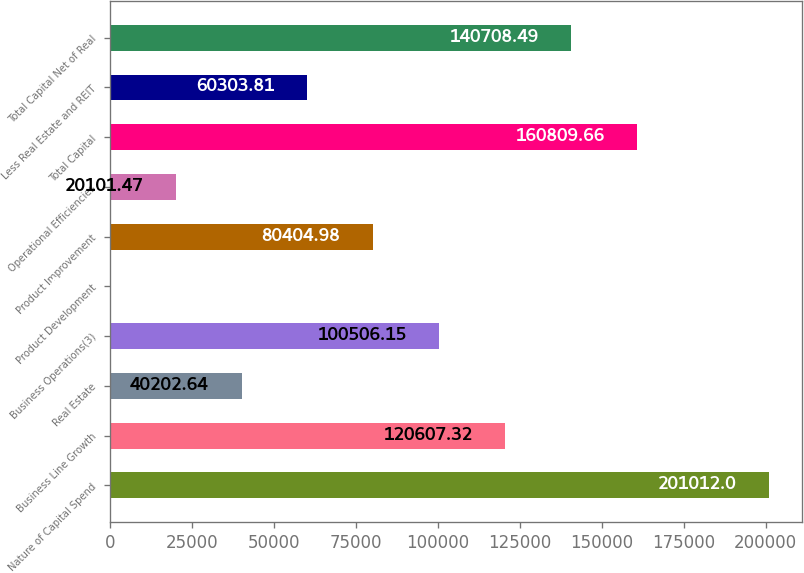<chart> <loc_0><loc_0><loc_500><loc_500><bar_chart><fcel>Nature of Capital Spend<fcel>Business Line Growth<fcel>Real Estate<fcel>Business Operations(3)<fcel>Product Development<fcel>Product Improvement<fcel>Operational Efficiencies<fcel>Total Capital<fcel>Less Real Estate and REIT<fcel>Total Capital Net of Real<nl><fcel>201012<fcel>120607<fcel>40202.6<fcel>100506<fcel>0.3<fcel>80405<fcel>20101.5<fcel>160810<fcel>60303.8<fcel>140708<nl></chart> 